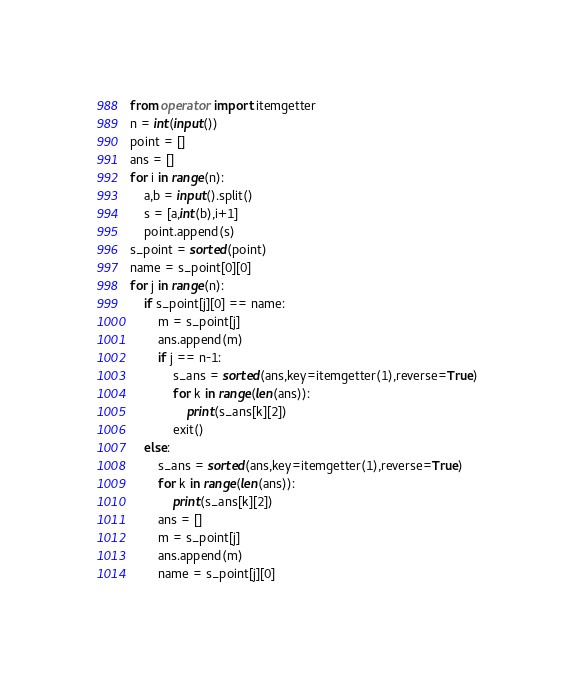Convert code to text. <code><loc_0><loc_0><loc_500><loc_500><_Python_>from operator import itemgetter 
n = int(input())
point = []
ans = []
for i in range(n):
    a,b = input().split()
    s = [a,int(b),i+1]
    point.append(s)
s_point = sorted(point)
name = s_point[0][0]
for j in range(n):
    if s_point[j][0] == name:
        m = s_point[j]
        ans.append(m)
        if j == n-1:
            s_ans = sorted(ans,key=itemgetter(1),reverse=True)
            for k in range(len(ans)):
                print(s_ans[k][2])
            exit()
    else:
        s_ans = sorted(ans,key=itemgetter(1),reverse=True)
        for k in range(len(ans)):
            print(s_ans[k][2])
        ans = []
        m = s_point[j]
        ans.append(m)
        name = s_point[j][0]</code> 